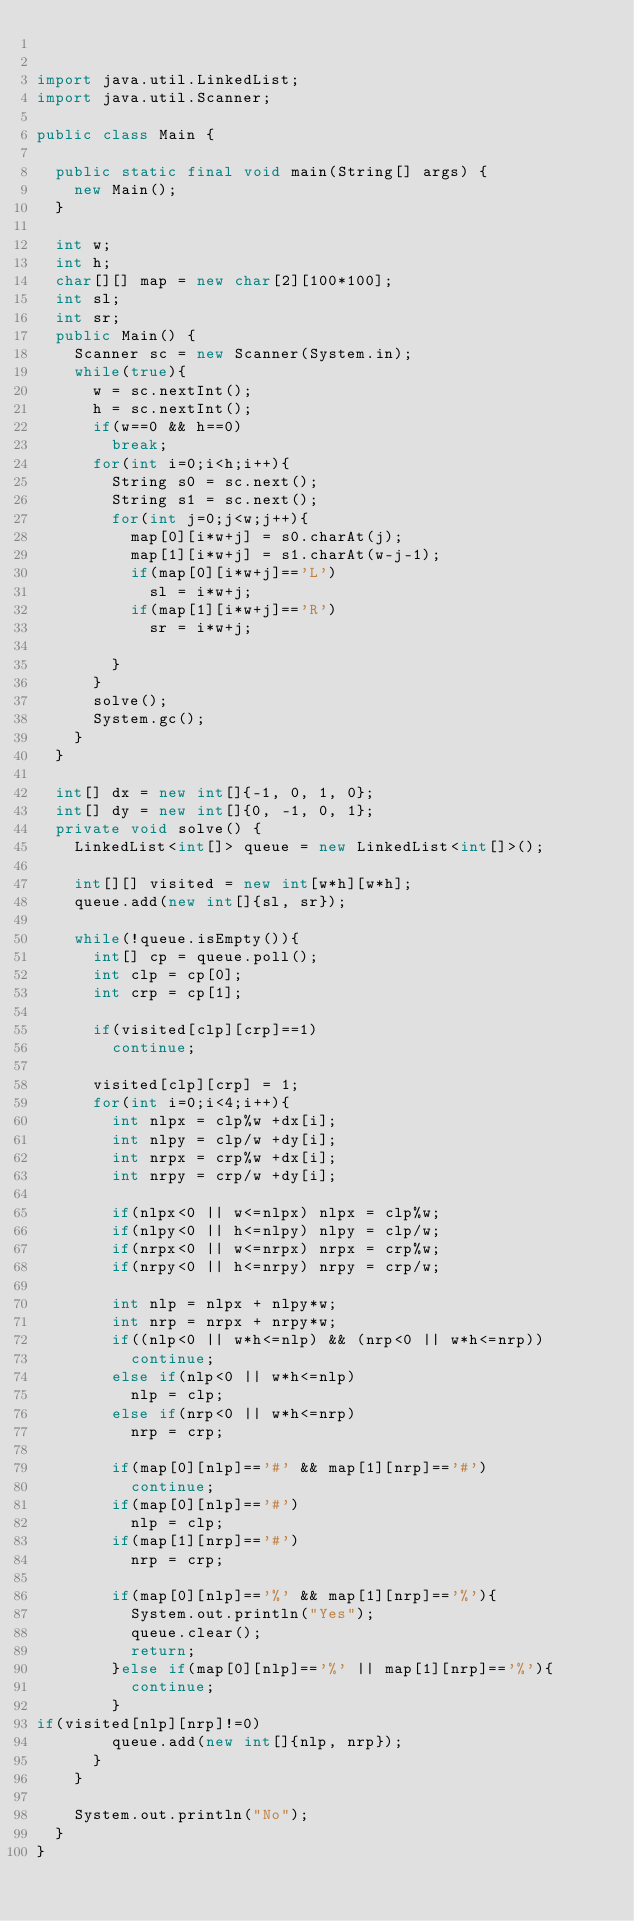<code> <loc_0><loc_0><loc_500><loc_500><_Java_>

import java.util.LinkedList;
import java.util.Scanner;

public class Main {

	public static final void main(String[] args) {
		new Main();
	}

	int w;
	int h;
	char[][] map = new char[2][100*100];
	int sl;
	int sr;
	public Main() {
		Scanner sc = new Scanner(System.in);
		while(true){
			w = sc.nextInt();
			h = sc.nextInt();
			if(w==0 && h==0)
				break;
			for(int i=0;i<h;i++){
				String s0 = sc.next();
				String s1 = sc.next();
				for(int j=0;j<w;j++){
					map[0][i*w+j] = s0.charAt(j);
					map[1][i*w+j] = s1.charAt(w-j-1);
					if(map[0][i*w+j]=='L')
						sl = i*w+j;
					if(map[1][i*w+j]=='R')
						sr = i*w+j;
					
				}
			}
			solve();
			System.gc();
		}
	}

	int[] dx = new int[]{-1, 0, 1, 0};
	int[] dy = new int[]{0, -1, 0, 1};
	private void solve() {
		LinkedList<int[]> queue = new LinkedList<int[]>();
		
		int[][] visited = new int[w*h][w*h];
		queue.add(new int[]{sl, sr});

		while(!queue.isEmpty()){
			int[] cp = queue.poll();
			int clp = cp[0];
			int crp = cp[1];
			
			if(visited[clp][crp]==1)
				continue;
			
			visited[clp][crp] = 1;
			for(int i=0;i<4;i++){
				int nlpx = clp%w +dx[i];
				int nlpy = clp/w +dy[i];
				int nrpx = crp%w +dx[i];
				int nrpy = crp/w +dy[i];
				
				if(nlpx<0 || w<=nlpx) nlpx = clp%w;
				if(nlpy<0 || h<=nlpy) nlpy = clp/w;
				if(nrpx<0 || w<=nrpx) nrpx = crp%w;
				if(nrpy<0 || h<=nrpy) nrpy = crp/w;
				
				int nlp = nlpx + nlpy*w;
				int nrp = nrpx + nrpy*w;
				if((nlp<0 || w*h<=nlp) && (nrp<0 || w*h<=nrp))
					continue;
				else if(nlp<0 || w*h<=nlp)
					nlp = clp;
				else if(nrp<0 || w*h<=nrp)
					nrp = crp;
				
				if(map[0][nlp]=='#' && map[1][nrp]=='#')
					continue;
				if(map[0][nlp]=='#')
					nlp = clp;
				if(map[1][nrp]=='#')
					nrp = crp;
				
				if(map[0][nlp]=='%' && map[1][nrp]=='%'){
					System.out.println("Yes");
					queue.clear();
					return;
				}else if(map[0][nlp]=='%' || map[1][nrp]=='%'){
					continue;
				}
if(visited[nlp][nrp]!=0)
				queue.add(new int[]{nlp, nrp});
			}
		}
		
		System.out.println("No");
	}
}</code> 